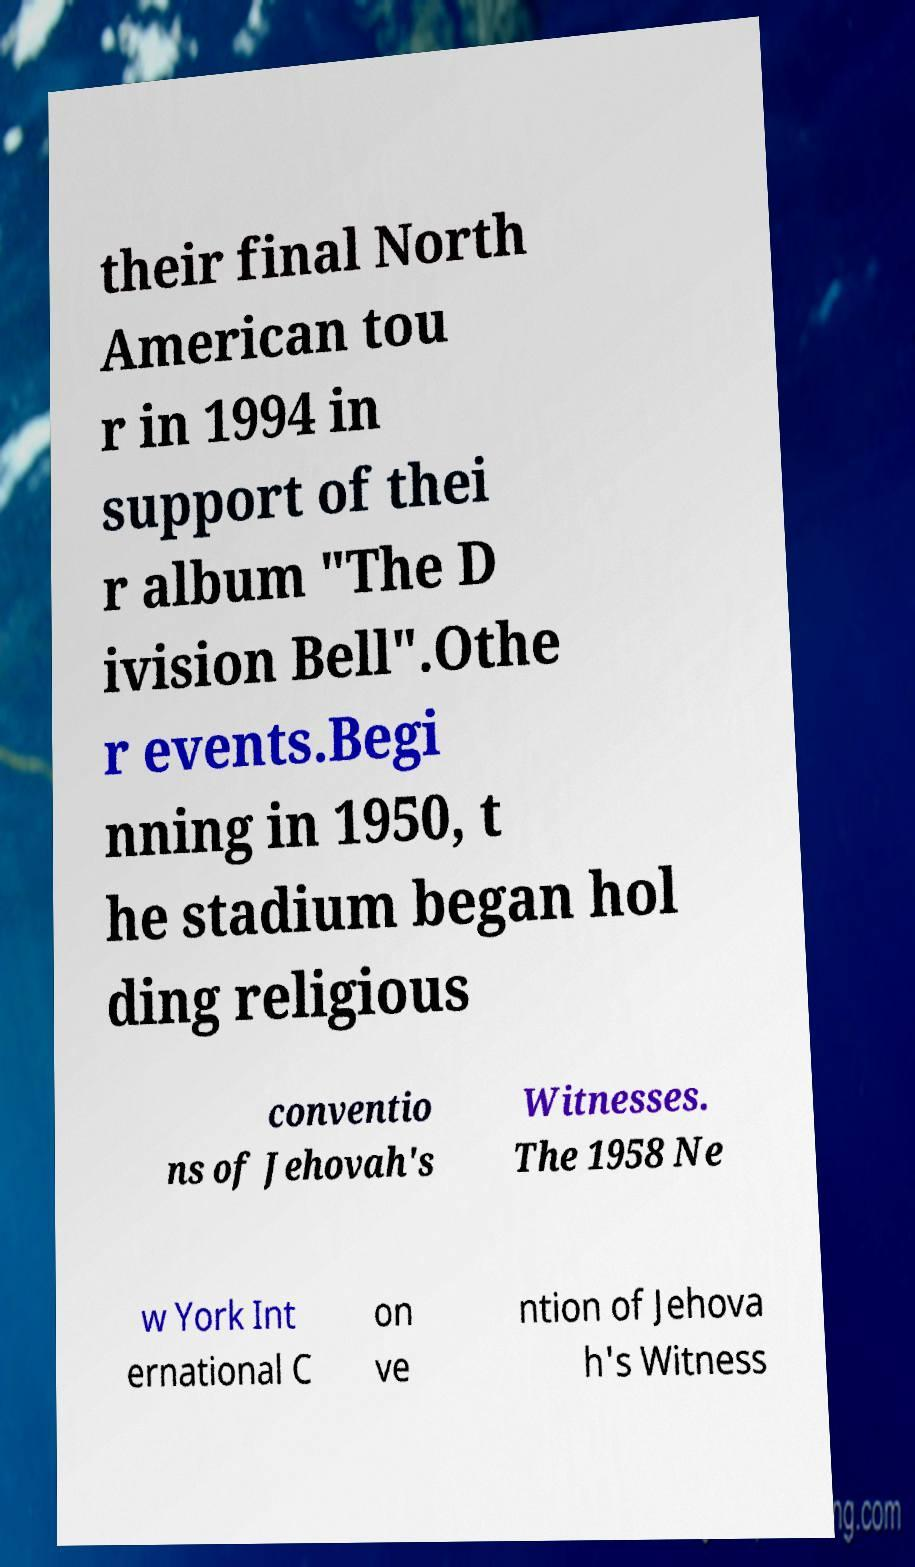I need the written content from this picture converted into text. Can you do that? their final North American tou r in 1994 in support of thei r album "The D ivision Bell".Othe r events.Begi nning in 1950, t he stadium began hol ding religious conventio ns of Jehovah's Witnesses. The 1958 Ne w York Int ernational C on ve ntion of Jehova h's Witness 